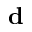Convert formula to latex. <formula><loc_0><loc_0><loc_500><loc_500>d</formula> 